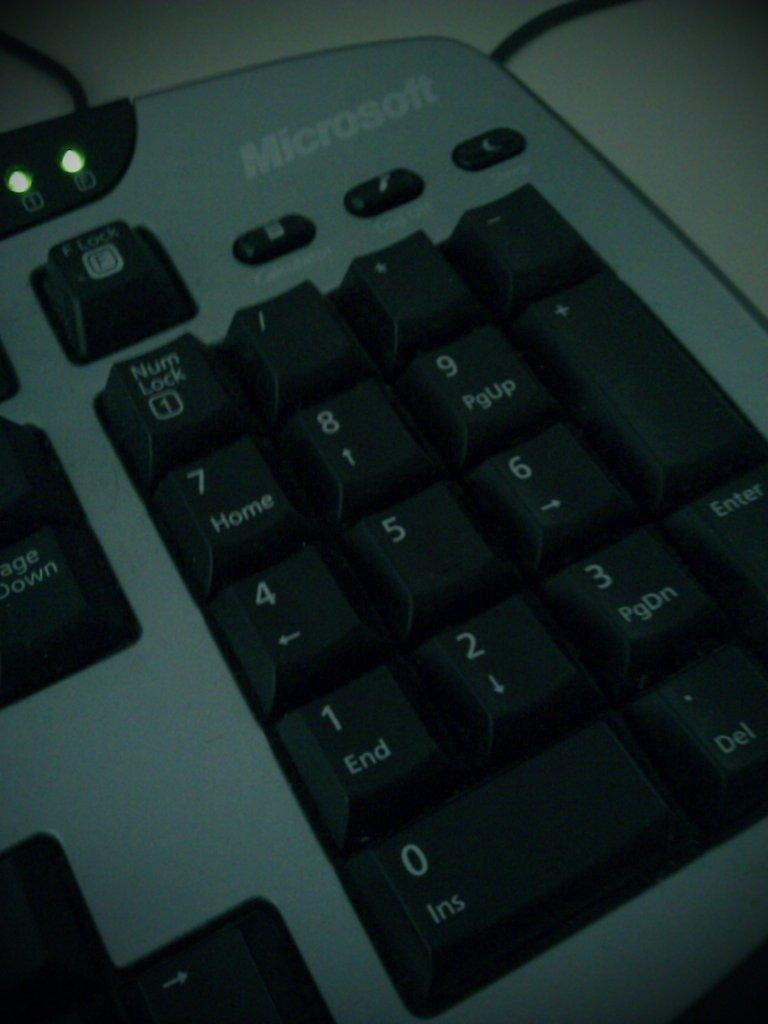<image>
Provide a brief description of the given image. Microsoft keyboard with black keys and the num lock near the top. 